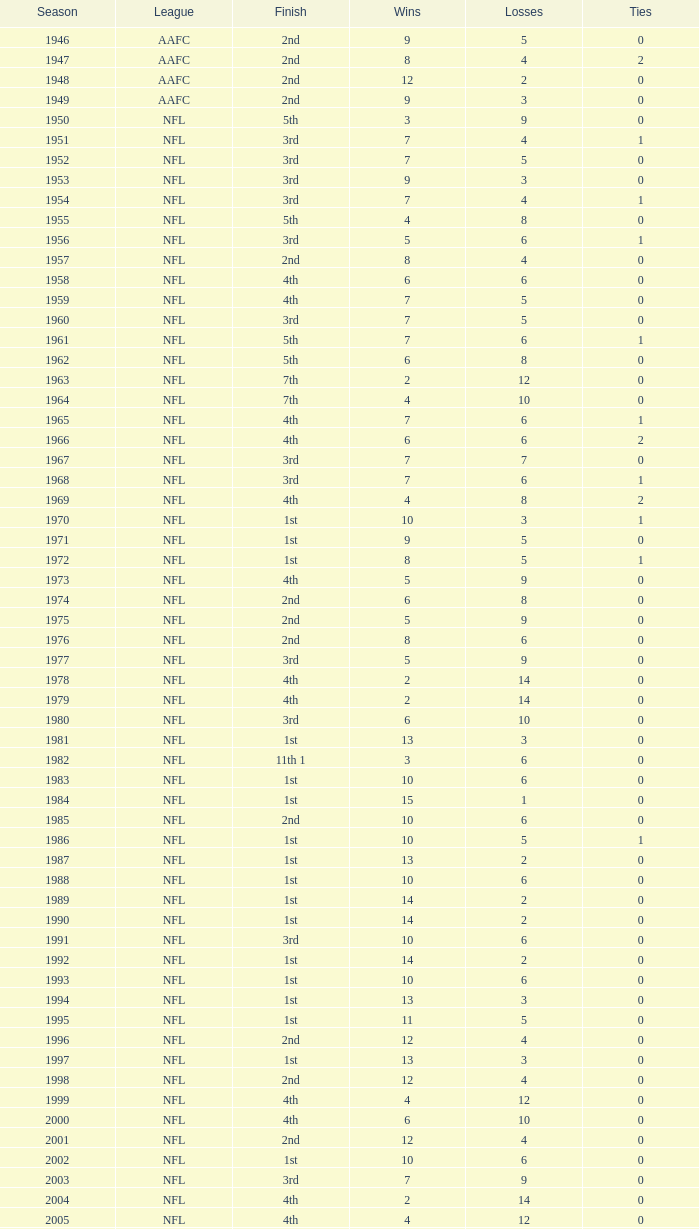What is the losses in the NFL in the 2011 season with less than 13 wins? None. 